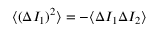<formula> <loc_0><loc_0><loc_500><loc_500>\langle ( \Delta I _ { 1 } ) ^ { 2 } \rangle = - \langle \Delta I _ { 1 } \Delta I _ { 2 } \rangle</formula> 